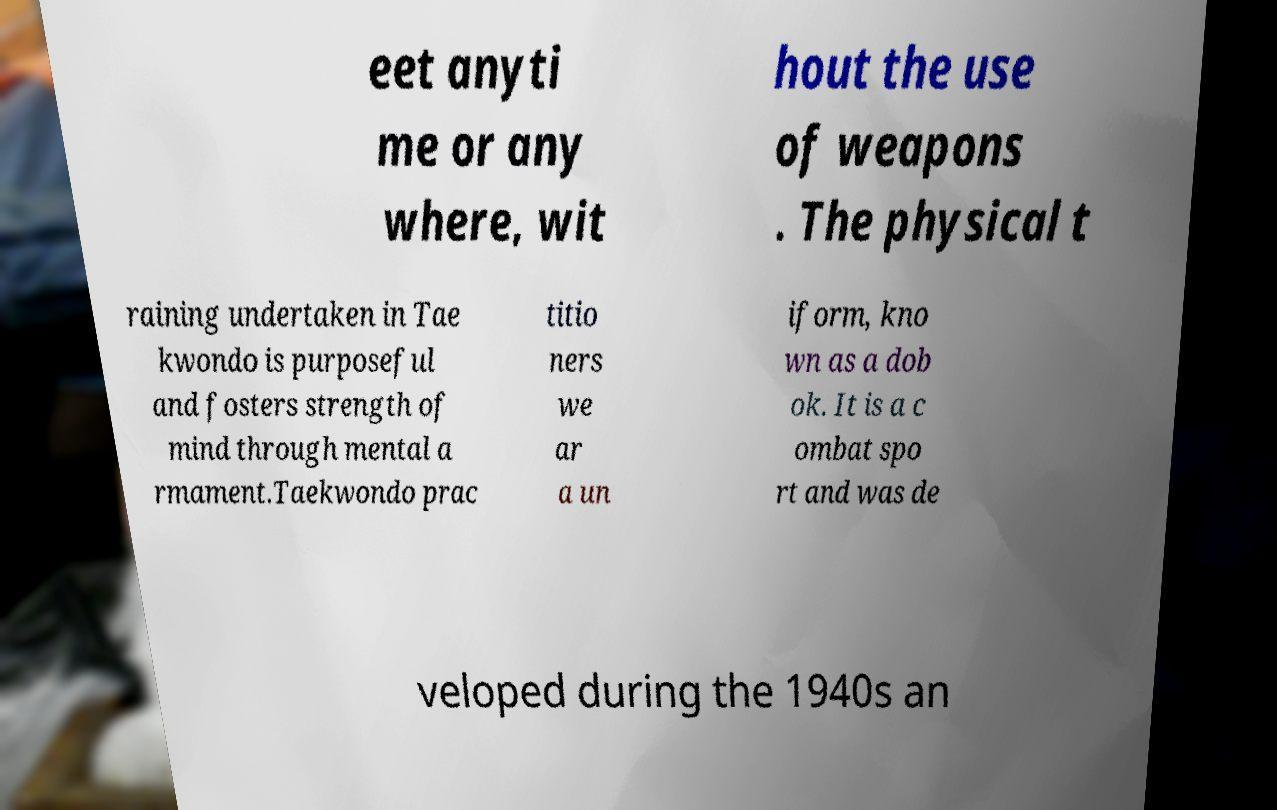Please identify and transcribe the text found in this image. eet anyti me or any where, wit hout the use of weapons . The physical t raining undertaken in Tae kwondo is purposeful and fosters strength of mind through mental a rmament.Taekwondo prac titio ners we ar a un iform, kno wn as a dob ok. It is a c ombat spo rt and was de veloped during the 1940s an 